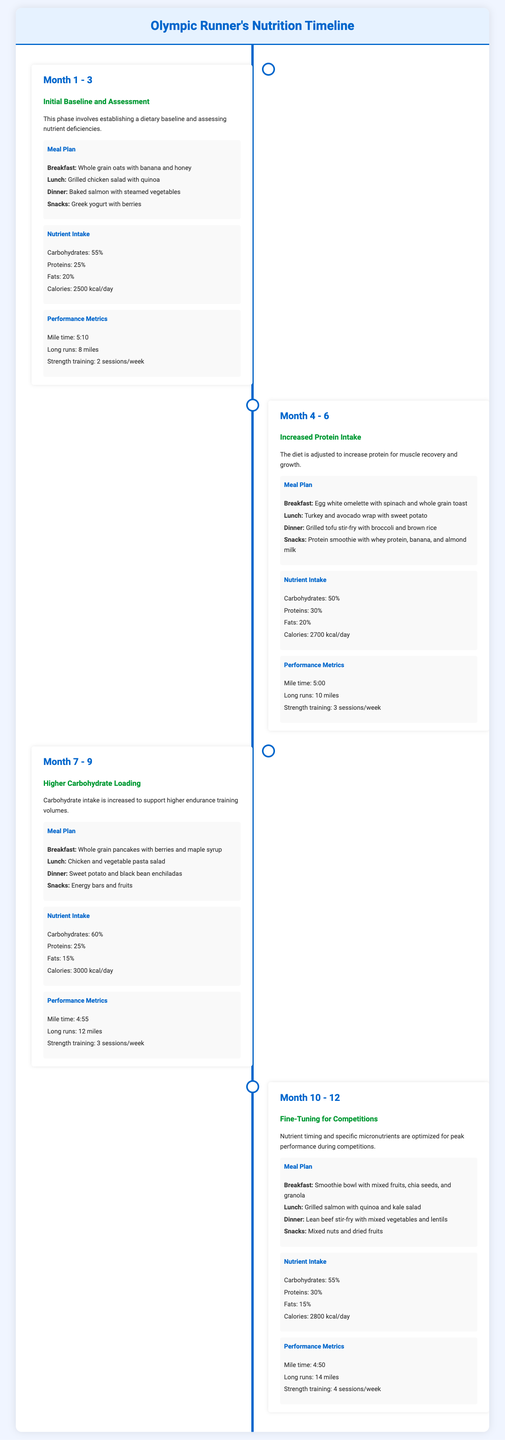What was the calorie intake in Month 1 - 3? The calorie intake for Month 1 - 3 is specified in the nutrient intake section.
Answer: 2500 kcal/day What nutrient percentage was highest in Month 7 - 9? The highest nutrient percentage in Month 7 - 9 is found in the nutrient intake section.
Answer: Carbohydrates: 60% Which meal was included in Month 4 - 6's dinner? The document mentions meals for each month, specifically for Month 4 - 6 in the meal plan section.
Answer: Grilled tofu stir-fry with broccoli and brown rice What improvement in mile time was seen from Month 1 - 3 to Month 10 - 12? The mile times from both sections can be compared to determine the improvement.
Answer: 20 seconds How many strength training sessions were scheduled in Month 10 - 12? This information can be retrieved from the performance metrics for Month 10 - 12.
Answer: 4 sessions/week What specific dietary adjustment was made in Month 4 - 6? The specific adjustment can be found in the section title for that timeframe.
Answer: Increased Protein Intake Which phase focused on carbohydrate loading? The phase can be identified from the section headings in the timeline.
Answer: Month 7 - 9 How many total months are covered in this nutrition timeline? The document can be reviewed to count the phases presented.
Answer: 12 months 